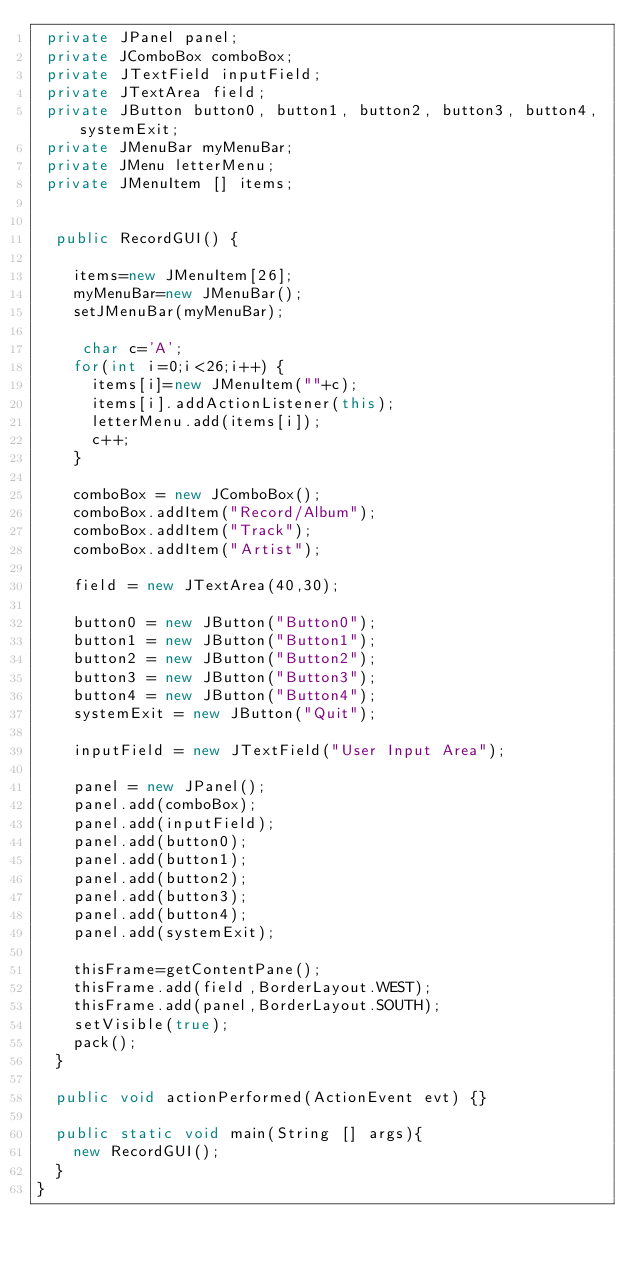Convert code to text. <code><loc_0><loc_0><loc_500><loc_500><_Java_> private JPanel panel;
 private JComboBox comboBox;
 private JTextField inputField;
 private JTextArea field;
 private JButton button0, button1, button2, button3, button4, systemExit;
 private JMenuBar myMenuBar;
 private JMenu letterMenu;
 private JMenuItem [] items;
  
  
  public RecordGUI() {
    
    items=new JMenuItem[26];
    myMenuBar=new JMenuBar();
    setJMenuBar(myMenuBar);
    
     char c='A';
    for(int i=0;i<26;i++) {
      items[i]=new JMenuItem(""+c);
      items[i].addActionListener(this);
      letterMenu.add(items[i]);
      c++;
    }
    
    comboBox = new JComboBox();
    comboBox.addItem("Record/Album");
    comboBox.addItem("Track");
    comboBox.addItem("Artist");
    
    field = new JTextArea(40,30);
    
    button0 = new JButton("Button0");
    button1 = new JButton("Button1");
    button2 = new JButton("Button2");
    button3 = new JButton("Button3");
    button4 = new JButton("Button4");
    systemExit = new JButton("Quit");
    
    inputField = new JTextField("User Input Area");
    
    panel = new JPanel();
    panel.add(comboBox);
    panel.add(inputField);
    panel.add(button0);
    panel.add(button1);
    panel.add(button2);
    panel.add(button3);
    panel.add(button4);
    panel.add(systemExit);
    
    thisFrame=getContentPane();
    thisFrame.add(field,BorderLayout.WEST);
    thisFrame.add(panel,BorderLayout.SOUTH);
    setVisible(true);
    pack();
  }
  
  public void actionPerformed(ActionEvent evt) {}
  
  public static void main(String [] args){
    new RecordGUI();
  }
}
    
    </code> 